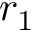Convert formula to latex. <formula><loc_0><loc_0><loc_500><loc_500>r _ { 1 }</formula> 